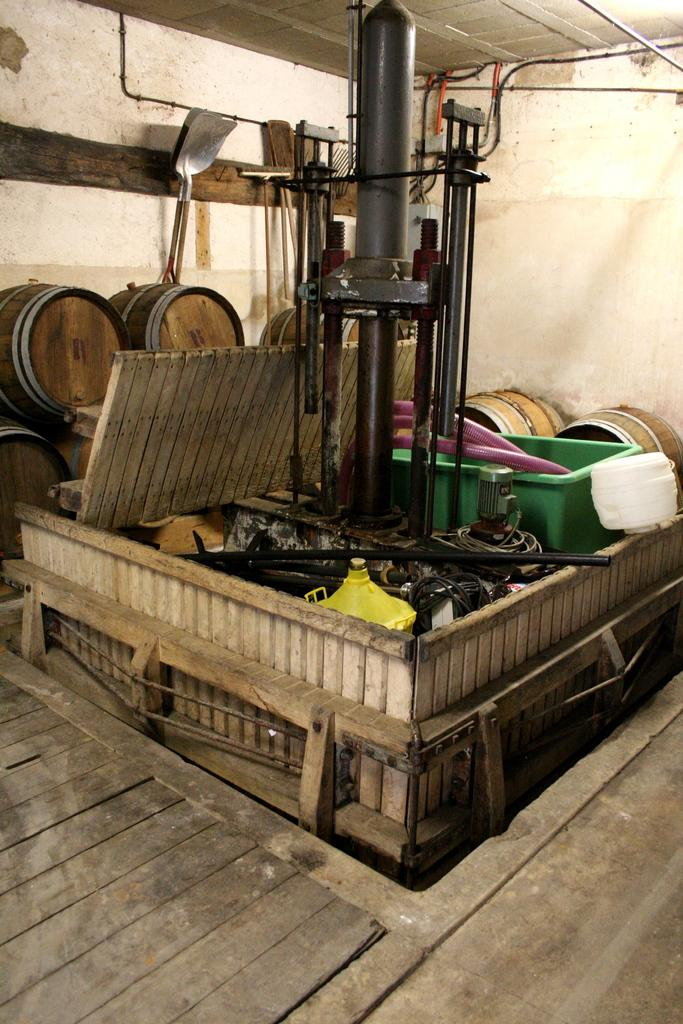What is the main object in the image? There is an equipment in the image. What can be seen under the equipment? The floor is visible in the image. What is present in the background of the image? There are barrels and a wall in the background of the image. Where is the mailbox located in the image? There is no mailbox present in the image. How many chickens can be seen in the image? There are no chickens present in the image. 